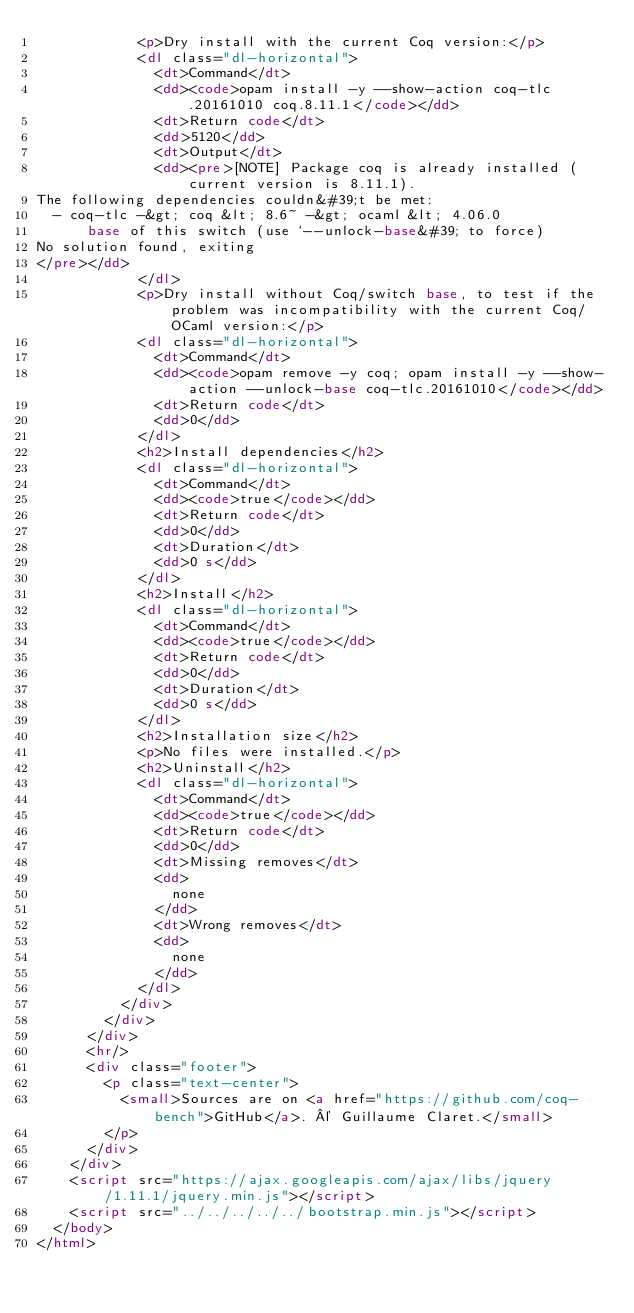Convert code to text. <code><loc_0><loc_0><loc_500><loc_500><_HTML_>            <p>Dry install with the current Coq version:</p>
            <dl class="dl-horizontal">
              <dt>Command</dt>
              <dd><code>opam install -y --show-action coq-tlc.20161010 coq.8.11.1</code></dd>
              <dt>Return code</dt>
              <dd>5120</dd>
              <dt>Output</dt>
              <dd><pre>[NOTE] Package coq is already installed (current version is 8.11.1).
The following dependencies couldn&#39;t be met:
  - coq-tlc -&gt; coq &lt; 8.6~ -&gt; ocaml &lt; 4.06.0
      base of this switch (use `--unlock-base&#39; to force)
No solution found, exiting
</pre></dd>
            </dl>
            <p>Dry install without Coq/switch base, to test if the problem was incompatibility with the current Coq/OCaml version:</p>
            <dl class="dl-horizontal">
              <dt>Command</dt>
              <dd><code>opam remove -y coq; opam install -y --show-action --unlock-base coq-tlc.20161010</code></dd>
              <dt>Return code</dt>
              <dd>0</dd>
            </dl>
            <h2>Install dependencies</h2>
            <dl class="dl-horizontal">
              <dt>Command</dt>
              <dd><code>true</code></dd>
              <dt>Return code</dt>
              <dd>0</dd>
              <dt>Duration</dt>
              <dd>0 s</dd>
            </dl>
            <h2>Install</h2>
            <dl class="dl-horizontal">
              <dt>Command</dt>
              <dd><code>true</code></dd>
              <dt>Return code</dt>
              <dd>0</dd>
              <dt>Duration</dt>
              <dd>0 s</dd>
            </dl>
            <h2>Installation size</h2>
            <p>No files were installed.</p>
            <h2>Uninstall</h2>
            <dl class="dl-horizontal">
              <dt>Command</dt>
              <dd><code>true</code></dd>
              <dt>Return code</dt>
              <dd>0</dd>
              <dt>Missing removes</dt>
              <dd>
                none
              </dd>
              <dt>Wrong removes</dt>
              <dd>
                none
              </dd>
            </dl>
          </div>
        </div>
      </div>
      <hr/>
      <div class="footer">
        <p class="text-center">
          <small>Sources are on <a href="https://github.com/coq-bench">GitHub</a>. © Guillaume Claret.</small>
        </p>
      </div>
    </div>
    <script src="https://ajax.googleapis.com/ajax/libs/jquery/1.11.1/jquery.min.js"></script>
    <script src="../../../../../bootstrap.min.js"></script>
  </body>
</html>
</code> 